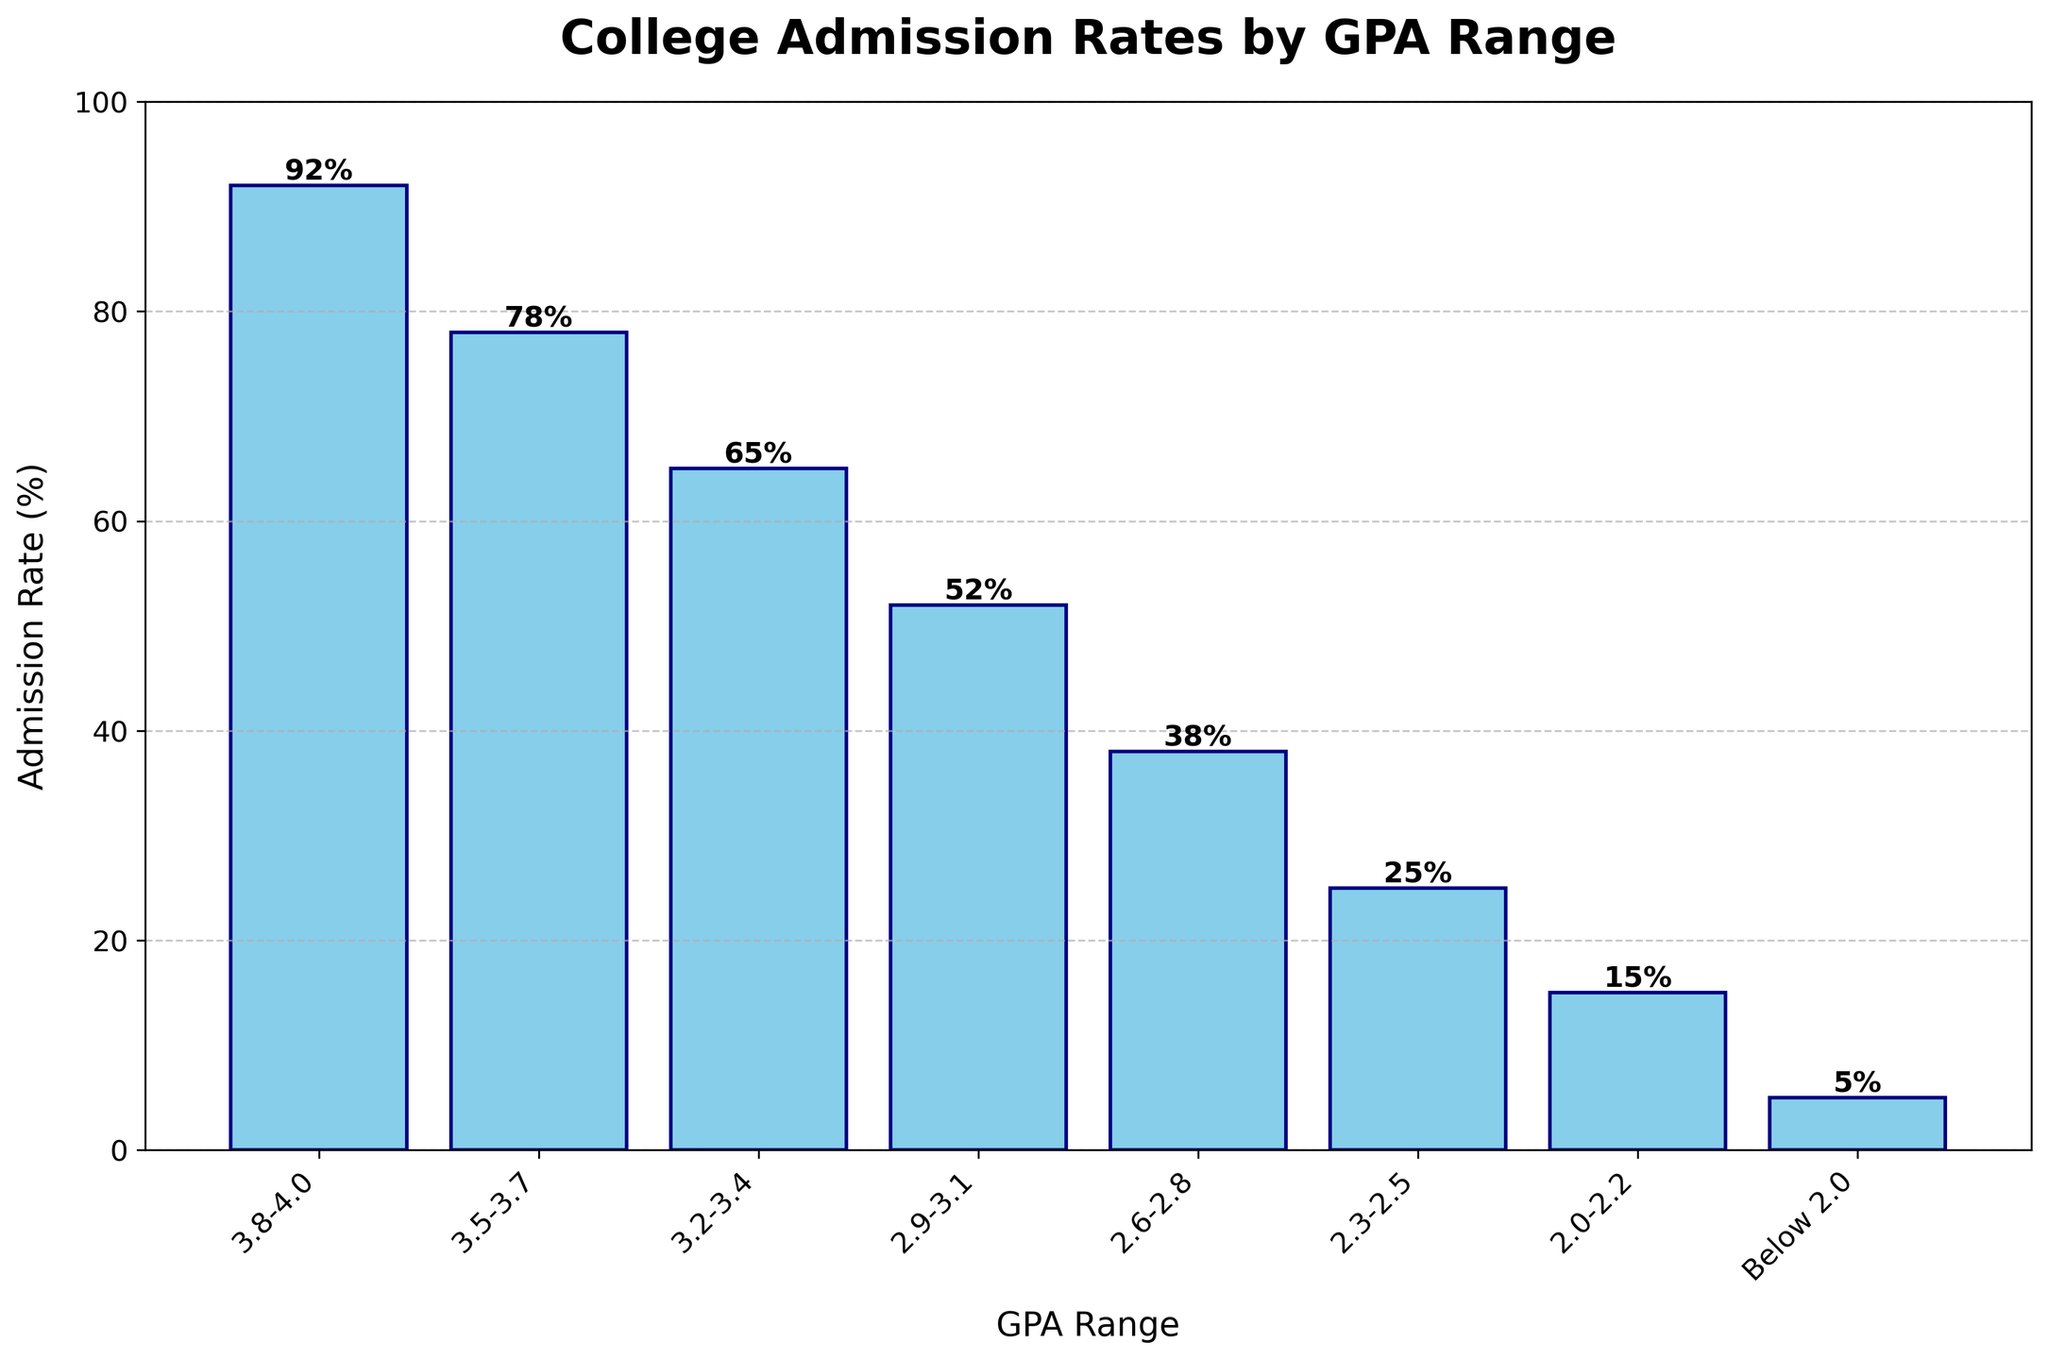What is the admission rate for the highest GPA range? The highest GPA range is 3.8-4.0, as seen at the beginning of the plot. The corresponding admission rate for this GPA range, shown on top of the bar, is 92%.
Answer: 92% What is the admission rate for students with a GPA range of 2.0-2.2? Looking at the bar corresponding to the GPA range of 2.0-2.2, the admission rate displayed above the bar is 15%.
Answer: 15% Which GPA range has the lowest admission rate, and what is the rate? The GPA range with the lowest bar height corresponds to Below 2.0. The admission rate above this bar is 5%.
Answer: Below 2.0, 5% Compare the admission rates for GPA ranges of 2.6-2.8 and 3.2-3.4. Which one is higher and by how much? The admission rate for 2.6-2.8 is 38%, and for 3.2-3.4 it is 65%. 65% is higher than 38% by 27%.
Answer: 3.2-3.4 is higher by 27% Calculate the average admission rate for GPA ranges above 3.0. The GPA ranges above 3.0 are 3.2-3.4 (65%), 3.5-3.7 (78%), and 3.8-4.0 (92%). Average = (65 + 78 + 92) / 3 = 78.33%.
Answer: 78.33% What percentage difference is there between the admission rates for GPA ranges 3.5-3.7 and 2.3-2.5? The admission rate for 3.5-3.7 is 78%, and for 2.3-2.5 it is 25%. Percentage difference = ((78 - 25) / 78) * 100 = 67.95%.
Answer: 67.95% What visual elements make it easy to distinguish between different GPA ranges in the bar chart? The use of different bar heights, consistent labeling with GPA ranges on the x-axis, and color/shading (skyblue with navy edges) make it easy to distinguish between different GPA range bars. Additionally, the admission rates are displayed on top of each bar for clarity.
Answer: Bar heights, labeling, colors Which GPA range shows an admission rate close to the midpoint between the highest and lowest admission rates? The highest admission rate is 92%, and the lowest is 5%. The midpoint is (92 + 5) / 2 = 48.5%. The closest admission rate to 48.5% is the 52% for the GPA range 2.9-3.1.
Answer: 2.9-3.1 How does the admission rate trend change as GPA ranges decrease from 3.8-4.0 to Below 2.0? As the GPA ranges decrease from 3.8-4.0 to Below 2.0, the admission rates also decrease significantly. The trend shows a downward pattern, starting from 92% and dropping progressively to 5%.
Answer: Decreases significantly 